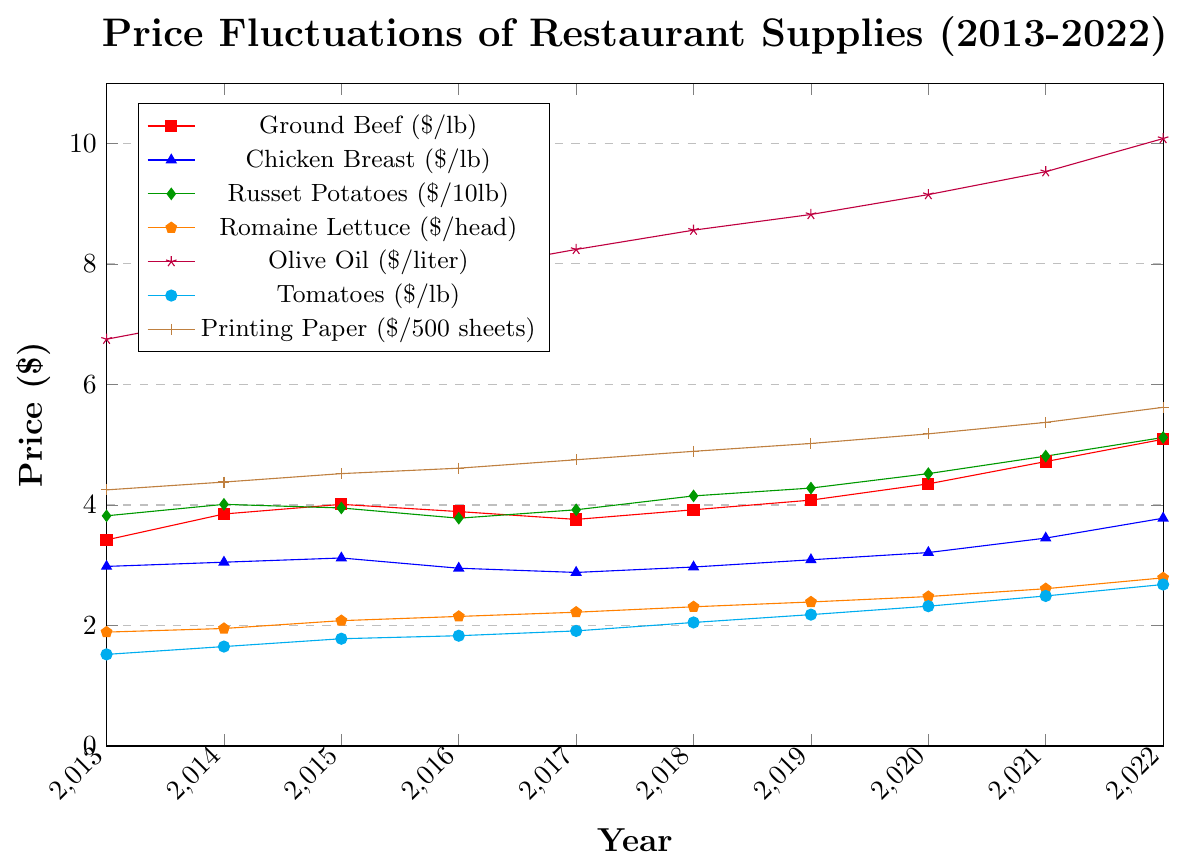What was the price difference between ground beef and chicken breast in 2013? In the plot, find the price for ground beef and chicken breast in 2013. Ground beef was $3.42 and chicken breast was $2.98. The difference is calculated as $3.42 - $2.98.
Answer: $0.44 Which ingredient saw the largest increase in price from 2013 to 2022? Compare the prices in 2013 and 2022 for all ingredients. Olive oil went from $6.75 in 2013 to $10.08 in 2022. This is an increase of $10.08 - $6.75 = $3.33. This is the largest increase compared to other ingredients.
Answer: Olive Oil How did the price of romaine lettuce change from 2015 to 2020? Compare the price of romaine lettuce in 2015 and 2020. In 2015, it was $2.08, and in 2020, it was $2.48. The change is $2.48 - $2.08.
Answer: $0.40 increase Which item had the highest price in 2016? Look at the data points for 2016 in the plot. Olive oil had the highest price at $7.89.
Answer: Olive Oil What is the average price of tomatoes from 2013 to 2022? Sum the prices of tomatoes for each year from 2013 to 2022 and divide by the number of years (10). The total is $1.52 + $1.65 + $1.78 + $1.83 + $1.91 + $2.05 + $2.18 + $2.32 + $2.49 + $2.68 = $21.41, so the average is $21.41 / 10.
Answer: $2.14 Which year had the biggest price increase for printing paper compared to the previous year? Calculate the yearly differences: 2014-2013: $4.38 - $4.25 = $0.13, 2015-2014: $4.52 - $4.38 = $0.14, 2016-2015: $4.61 - $4.52 = $0.09, 2017-2016: $4.75 - $4.61 = $0.14, 2018-2017: $4.89 - $4.75 = $0.14, 2019-2018: $5.02 - $4.89 = $0.13, 2020-2019: $5.18 - $5.02 = $0.16, 2021-2020: $5.37 - $5.18 = $0.19, 2022-2021: $5.62 - $5.37 = $0.25. 2022 has the largest increase of $0.25.
Answer: 2022 Was the price of chicken breast ever higher than ground beef in any given year? Compare the line plots of chicken breast and ground beef for all years. The price of chicken breast was never higher than ground beef in any given year.
Answer: No What is the price trend of olive oil over the decade? Observing the plot, the price of olive oil consistently increased yearly from 2013 ($6.75) to 2022 ($10.08).
Answer: Increasing trend Which year had the closest prices between tomatoes and romaine lettuce? Calculate the yearly differences: 2013: $1.52-$1.89=$0.37, 2014: $1.65-$1.95=$0.30, 2015: $1.78-$2.08=$0.30, 2016: $1.83-$2.15=$0.32, 2017: $1.91-$2.22=$0.31, 2018: $2.05-$2.31=$0.26, 2019: $2.18-$2.39=$0.21, 2020: $2.32-$2.48=$0.16, 2021: $2.49-$2.61=$0.12, 2022: $2.68-$2.79=$0.11. The closest prices were in 2022 with a $0.11 difference.
Answer: 2022 By how much did the price of russet potatoes increase from 2020 to 2022? Compare the price of russet potatoes in 2020 ($4.52) to 2022 ($5.12). The change is $5.12 - $4.52.
Answer: $0.60 